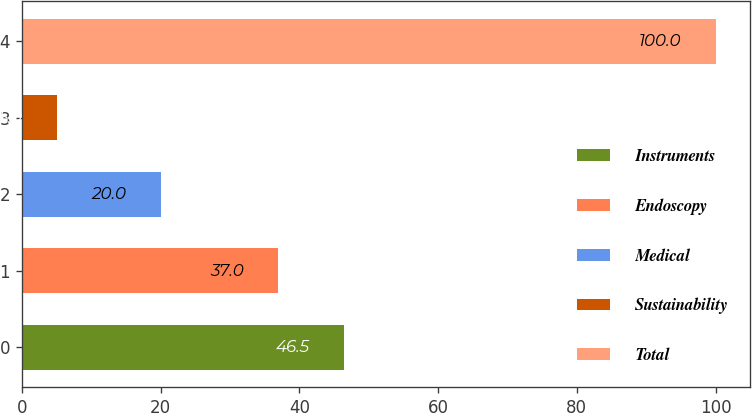Convert chart to OTSL. <chart><loc_0><loc_0><loc_500><loc_500><bar_chart><fcel>Instruments<fcel>Endoscopy<fcel>Medical<fcel>Sustainability<fcel>Total<nl><fcel>46.5<fcel>37<fcel>20<fcel>5<fcel>100<nl></chart> 